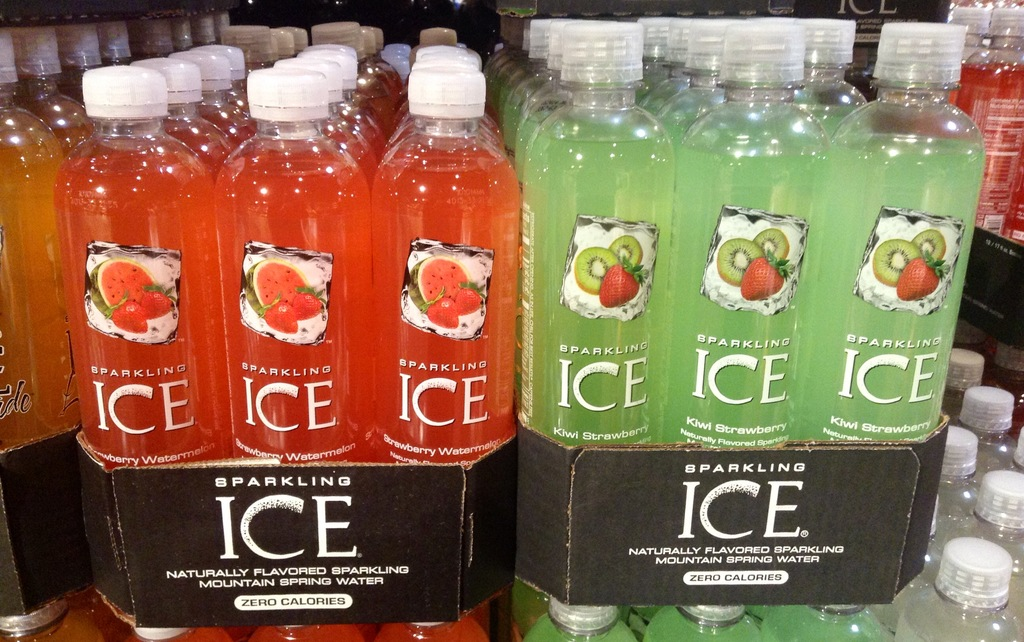Provide a one-sentence caption for the provided image. Rows of Sparkling Ice bottled water, featuring Zero Calories and naturally flavored varieties such as Strawberry Watermelon and Kiwi Strawberry. 